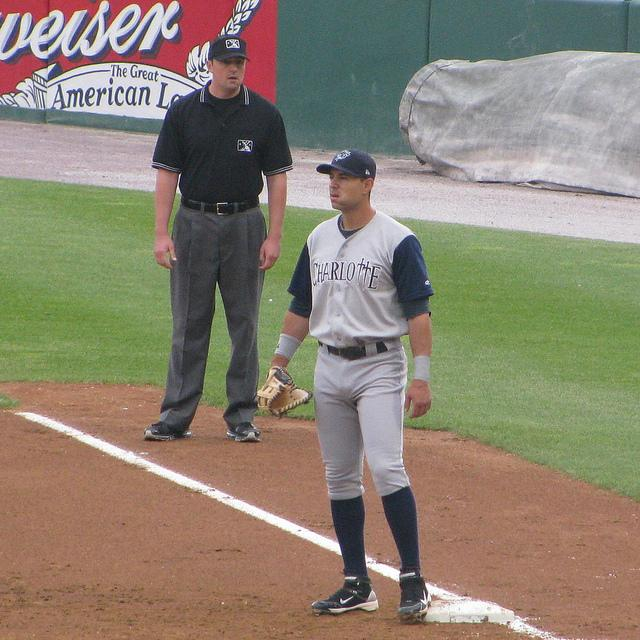What is the person dress in black's job?

Choices:
A) umpire
B) referee
C) 1st base
D) catcher referee 